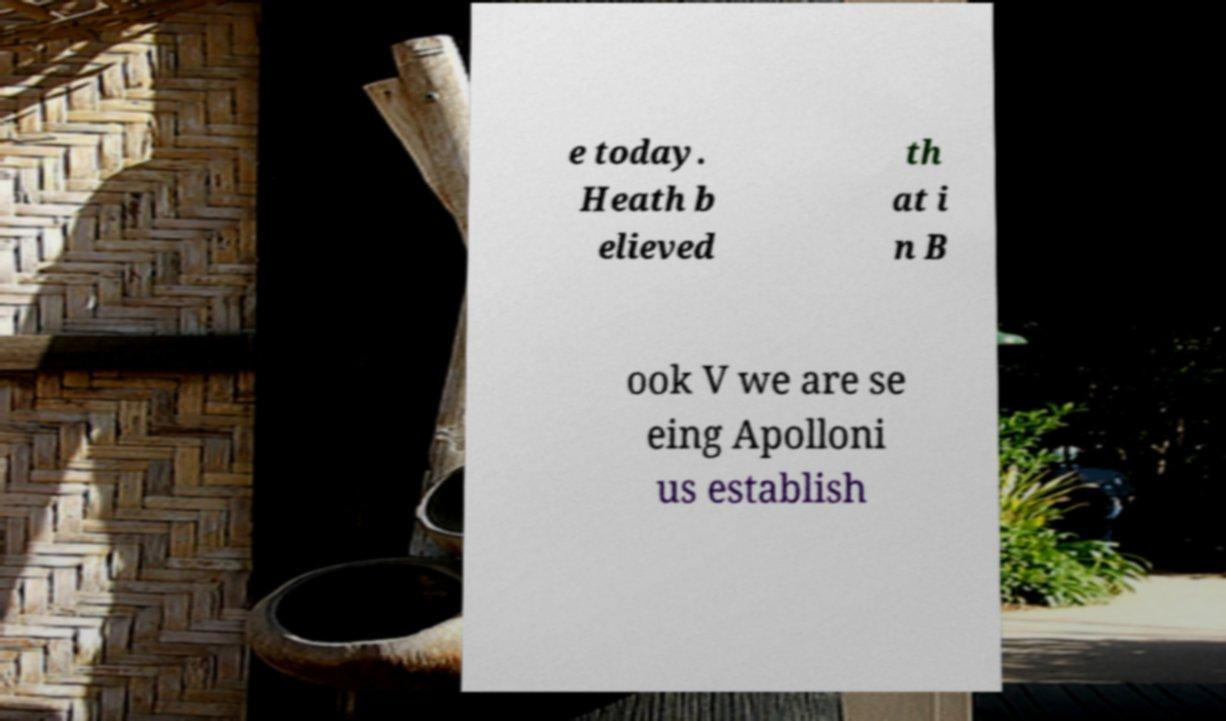Can you accurately transcribe the text from the provided image for me? e today. Heath b elieved th at i n B ook V we are se eing Apolloni us establish 